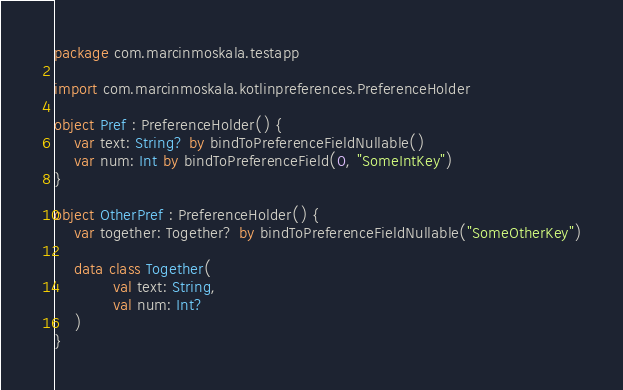Convert code to text. <code><loc_0><loc_0><loc_500><loc_500><_Kotlin_>package com.marcinmoskala.testapp

import com.marcinmoskala.kotlinpreferences.PreferenceHolder

object Pref : PreferenceHolder() {
    var text: String? by bindToPreferenceFieldNullable()
    var num: Int by bindToPreferenceField(0, "SomeIntKey")
}

object OtherPref : PreferenceHolder() {
    var together: Together? by bindToPreferenceFieldNullable("SomeOtherKey")

    data class Together(
            val text: String,
            val num: Int?
    )
}</code> 